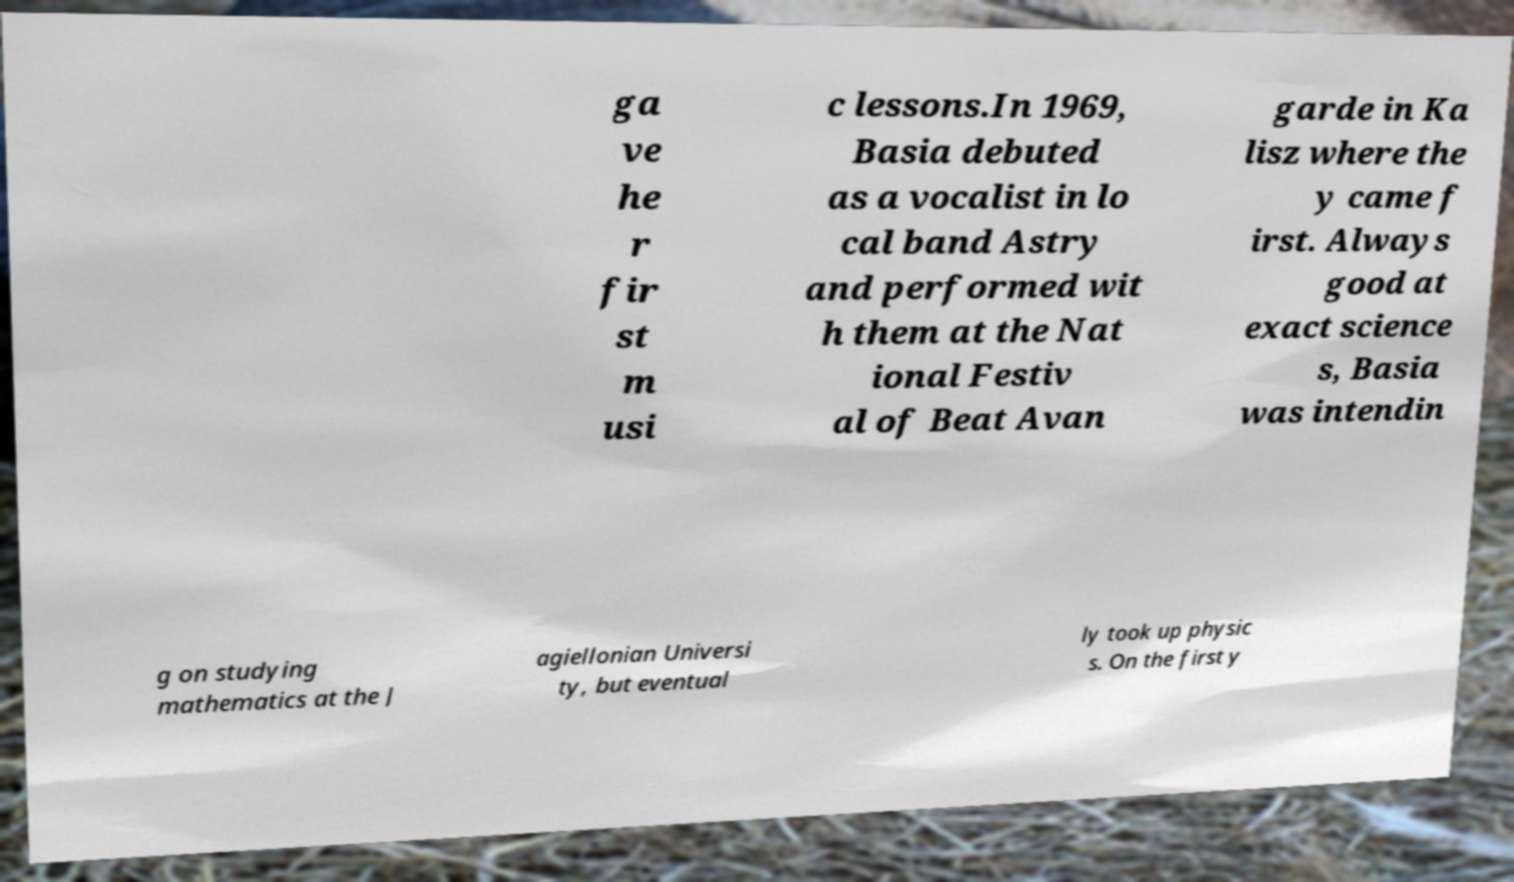Can you accurately transcribe the text from the provided image for me? ga ve he r fir st m usi c lessons.In 1969, Basia debuted as a vocalist in lo cal band Astry and performed wit h them at the Nat ional Festiv al of Beat Avan garde in Ka lisz where the y came f irst. Always good at exact science s, Basia was intendin g on studying mathematics at the J agiellonian Universi ty, but eventual ly took up physic s. On the first y 